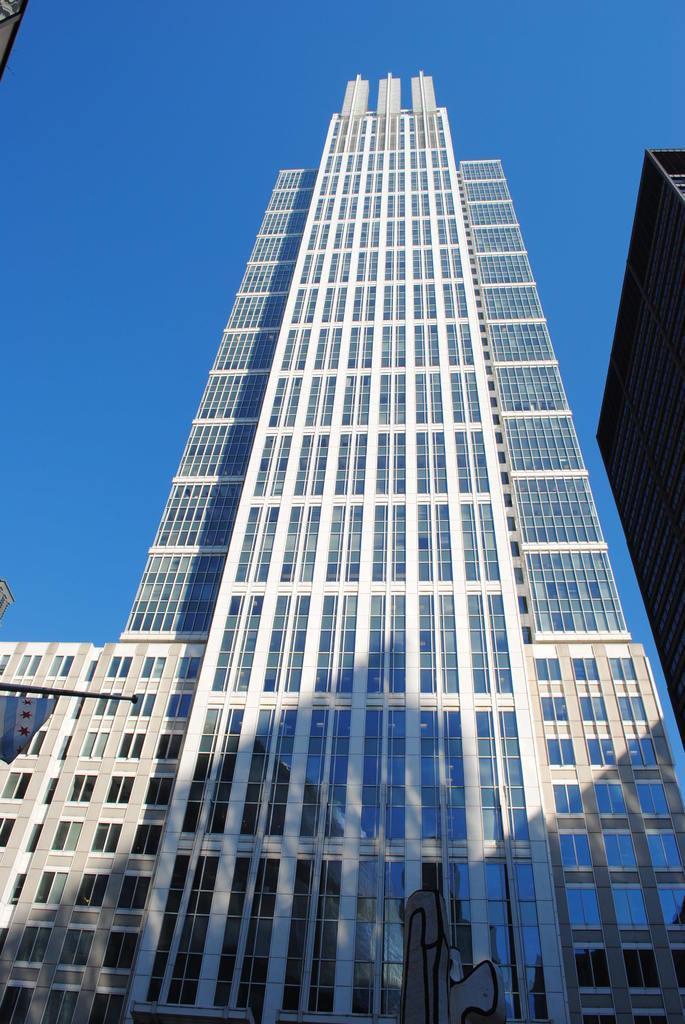What structures are present in the image? There are buildings in the image. What can be seen in the background of the image? The sky is visible in the background of the image. How would you describe the sky in the image? The sky appears to be clear in the image. How many cherries are hanging from the buildings in the image? There are no cherries present in the image; it features buildings and a clear sky. 